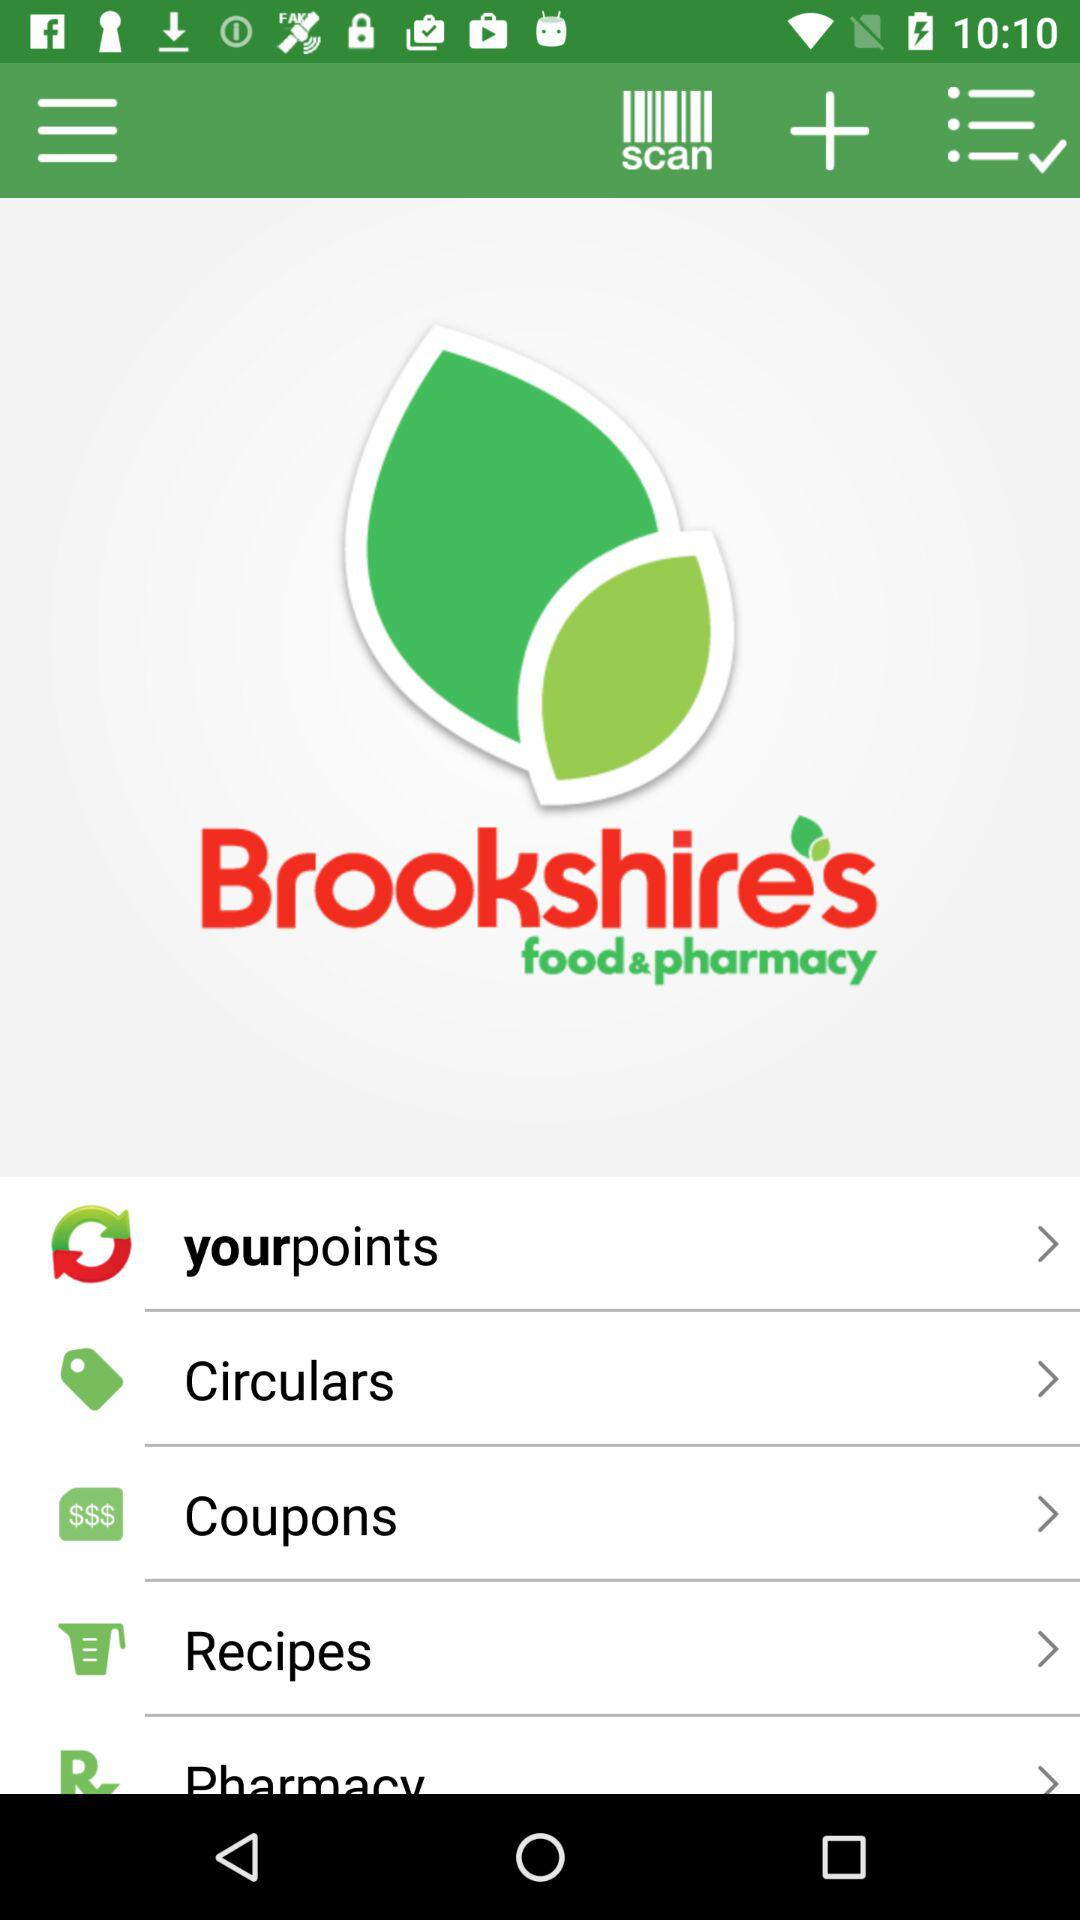What is the name of the application? The application name is "Brookshire's food & pharmacy". 